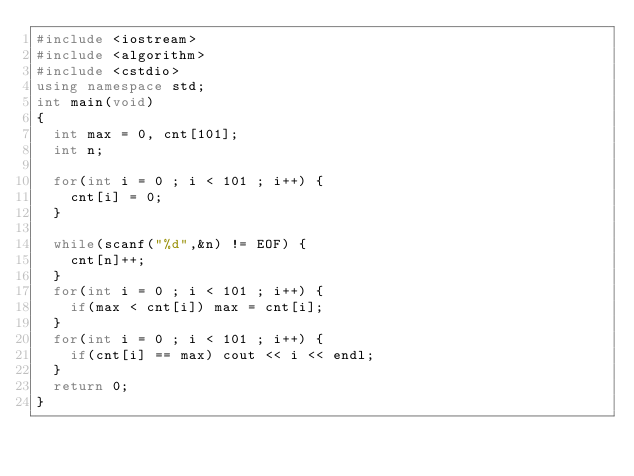Convert code to text. <code><loc_0><loc_0><loc_500><loc_500><_C++_>#include <iostream>
#include <algorithm>
#include <cstdio>
using namespace std;
int main(void)
{
  int max = 0, cnt[101];
  int n;

  for(int i = 0 ; i < 101 ; i++) {
    cnt[i] = 0;
  }

  while(scanf("%d",&n) != EOF) {
    cnt[n]++;
  }
  for(int i = 0 ; i < 101 ; i++) {
    if(max < cnt[i]) max = cnt[i];
  }
  for(int i = 0 ; i < 101 ; i++) {
    if(cnt[i] == max) cout << i << endl;
  }
  return 0;
}</code> 